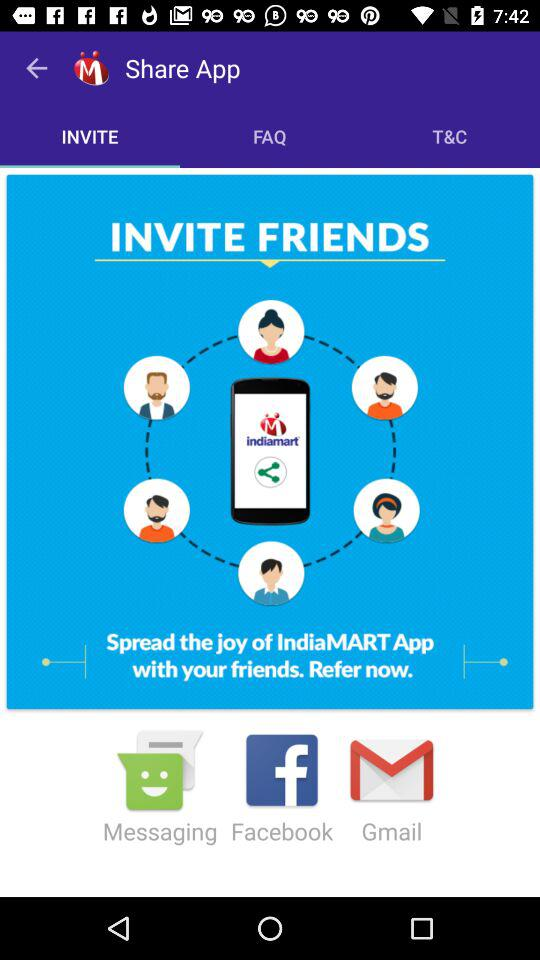Through which apps can we invite friends? You can invite friends through "Messaging", "Facebook" and "Gmail". 